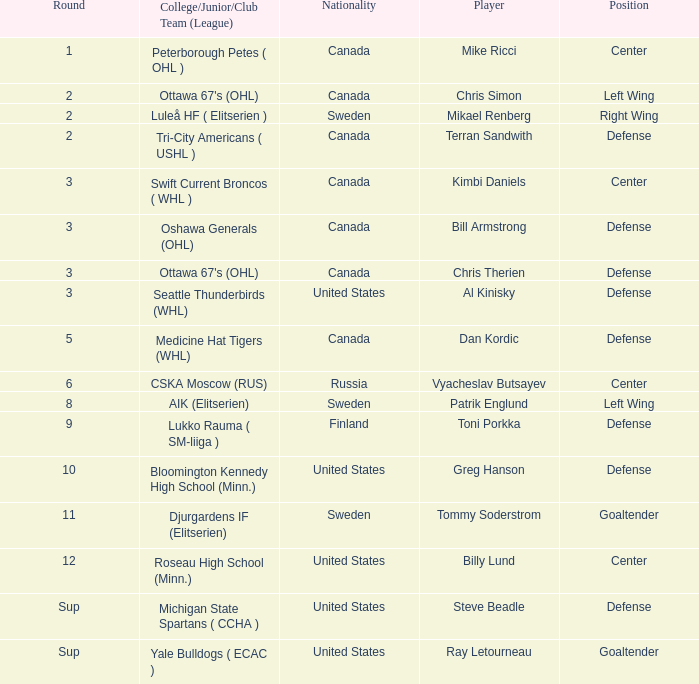What player is playing on round 1 Mike Ricci. 